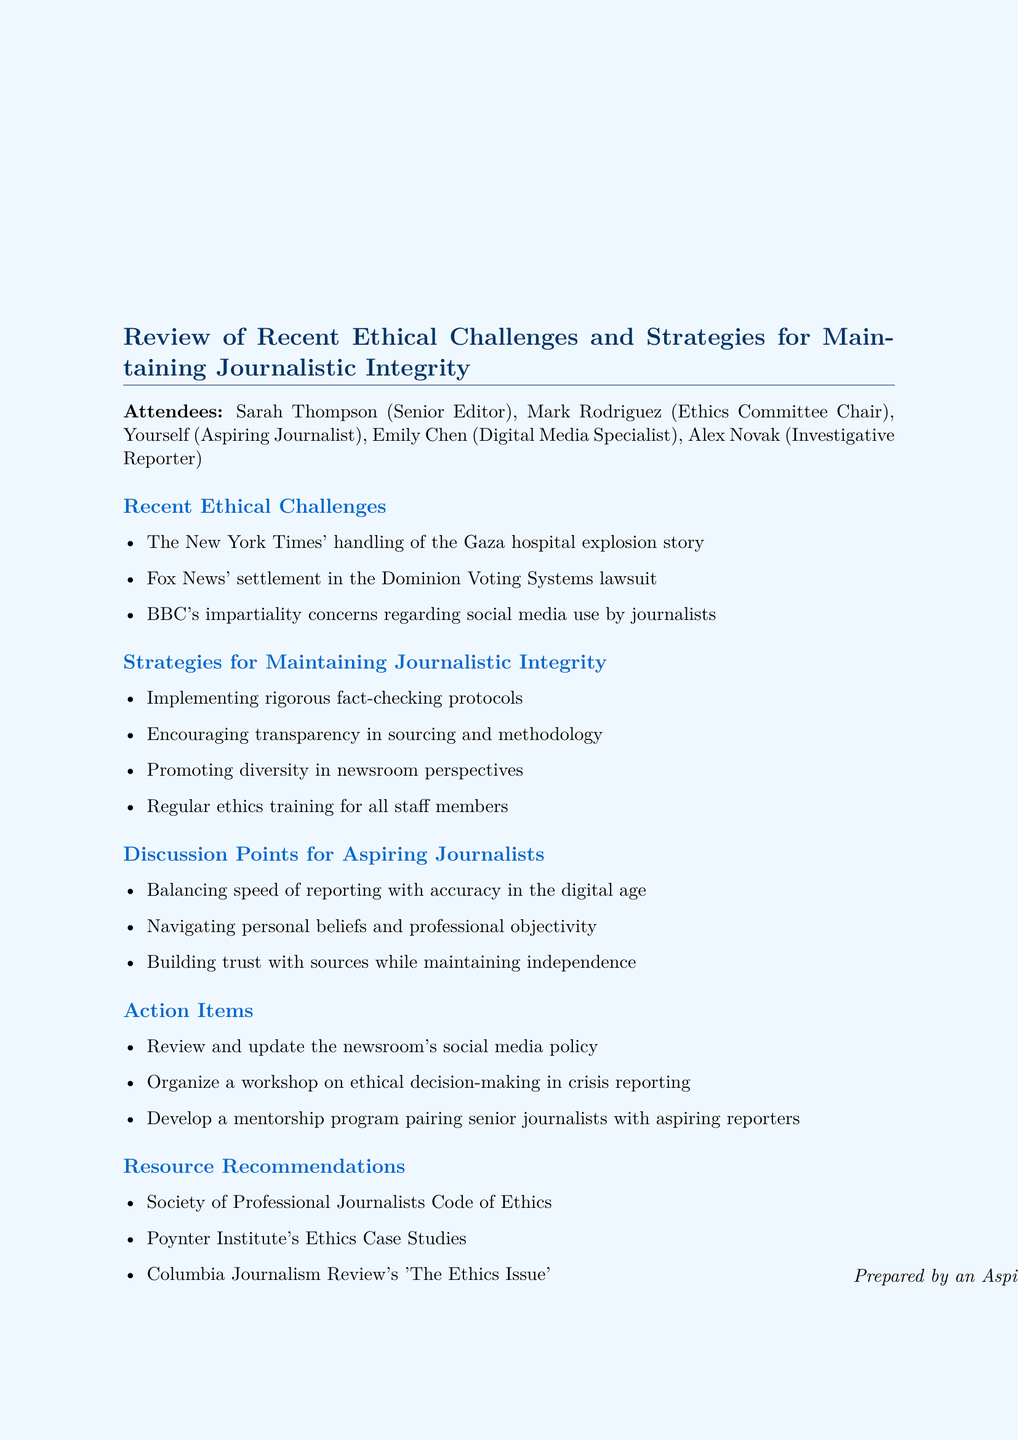What was one recent ethical challenge discussed in the meeting? The meeting highlighted specific ethical challenges faced by news organizations, including the handling of a particular story.
Answer: The New York Times' handling of the Gaza hospital explosion story Who chaired the Ethics Committee? The document lists the attendees, including the role of the individual overseeing ethical discussions.
Answer: Mark Rodriguez What is one strategy for maintaining journalistic integrity mentioned? The meeting outlined multiple strategies aimed at preserving the integrity of journalism.
Answer: Implementing rigorous fact-checking protocols How many discussion points for aspiring journalists were noted in the meeting? The number of topics aimed at guiding aspiring journalists was shared during the meeting.
Answer: Three What is one action item proposed for the newsroom? The document includes specific action items aimed at enhancing newsroom practices.
Answer: Review and update the newsroom's social media policy Which resource focuses on ethics case studies? Among the recommended resources, one specifically deals with case studies in journalism ethics.
Answer: Poynter Institute's Ethics Case Studies 